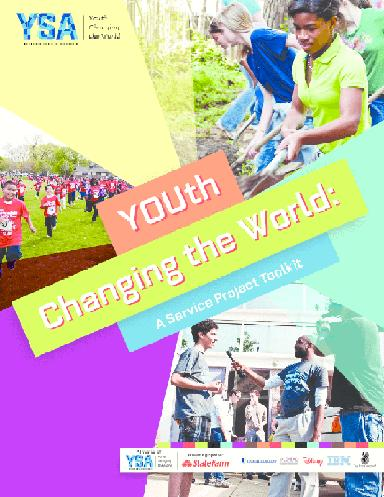What is the main message on the brochure? The brochure emphatically promotes 'Youth Changing the World' as its core message, aiming to inspire young individuals to take action and make a positive impact on their communities and beyond. This slogan serves as a rallying cry, encouraging youth participation in transformative service projects. 